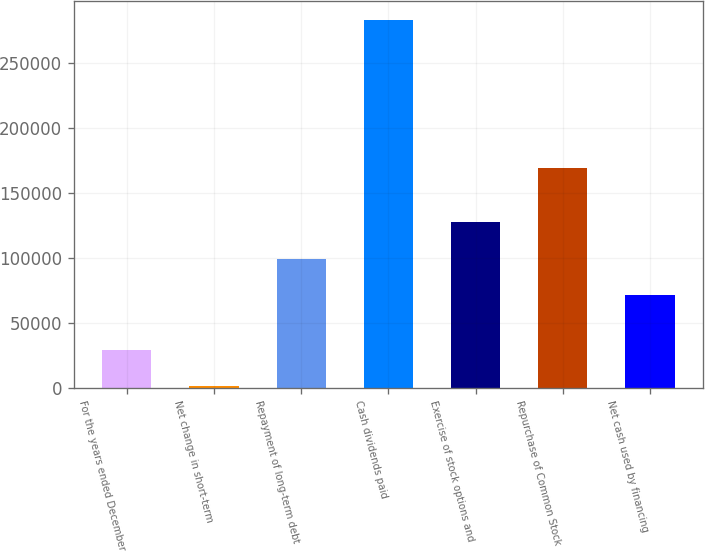Convert chart. <chart><loc_0><loc_0><loc_500><loc_500><bar_chart><fcel>For the years ended December<fcel>Net change in short-term<fcel>Repayment of long-term debt<fcel>Cash dividends paid<fcel>Exercise of stock options and<fcel>Repurchase of Common Stock<fcel>Net cash used by financing<nl><fcel>29383.8<fcel>1156<fcel>99327.8<fcel>283434<fcel>127556<fcel>169099<fcel>71100<nl></chart> 